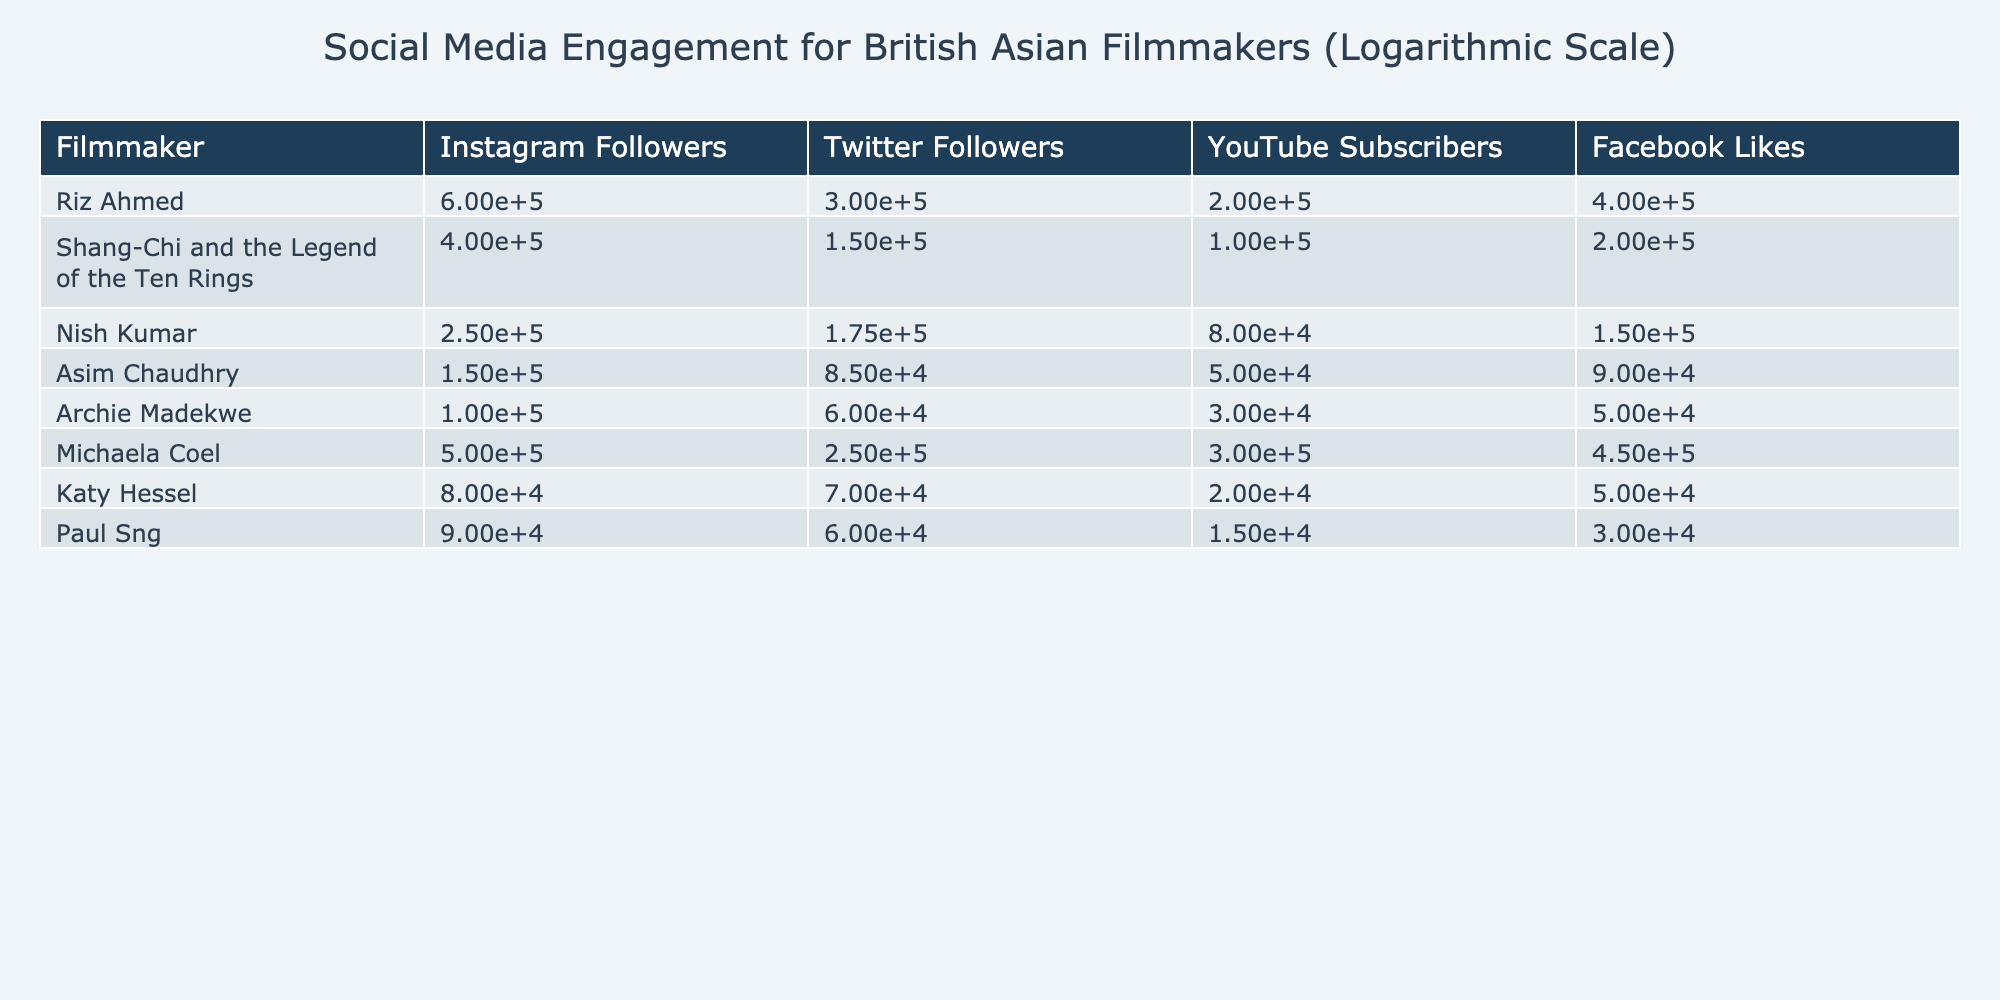What is the highest number of Instagram followers among the filmmakers listed? The table shows the Instagram follower counts, and Riz Ahmed has 600,000 followers, which is higher than all the other filmmakers listed.
Answer: 600000 How many more Twitter followers does Michaela Coel have than Paul Sng? Michaela Coel has 250,000 Twitter followers and Paul Sng has 60,000. To find the difference: 250,000 - 60,000 = 190,000.
Answer: 190000 Is Asim Chaudhry's Facebook Likes greater than Katy Hessel's? Asim Chaudhry has 90,000 Facebook Likes and Katy Hessel has 50,000. Since 90,000 is greater than 50,000, the statement is true.
Answer: Yes What is the average number of YouTube Subscribers for the filmmakers? The total number of YouTube Subscribers is 200,000 + 100,000 + 80,000 + 50,000 + 30,000 + 300,000 + 20,000 + 15,000 = 795,000. There are 8 filmmakers, so the average is 795,000 / 8 = 99,375.
Answer: 99375 Which filmmaker has the least number of Facebook Likes? In the table, the lowest Facebook Likes are for Paul Sng at 30,000. This is compared with the others, confirming that no filmmaker has less.
Answer: Paul Sng What percentage of Riz Ahmed's followers come from Instagram compared to his combined social media presence? Total followers across all platforms for Riz Ahmed is 600,000 (Instagram) + 300,000 (Twitter) + 200,000 (YouTube) + 400,000 (Facebook) = 1,500,000. The percentage of Instagram followers is (600,000 / 1,500,000) * 100 = 40%.
Answer: 40% How does the total Facebook Likes for Nish Kumar compare to that of Michaela Coel? Nish Kumar has 150,000 Facebook Likes, while Michaela Coel has 450,000. Michaela Coel has 450,000 - 150,000 = 300,000 more Likes.
Answer: 300000 more If we consider only the filmmakers with over 200,000 YouTube subscribers, how many unique platforms do they have data for? The filmmakers are Riz Ahmed (200,000), Michaela Coel (300,000), and Shang-Chi (100,000). All three filmmakers have data for 4 platforms each: Instagram, Twitter, YouTube, and Facebook, totaling 12 unique data points with three filmmakers.
Answer: 12 What is the total number of Instagram followers among the filmmakers listed below Katy Hessel? The filmmakers below Katy Hessel based on Instagram followers are Paul Sng (90,000), Archie Madekwe (100,000), Asim Chaudhry (150,000), Nish Kumar (250,000), and Riz Ahmed (600,000). Their total is 90,000 + 100,000 + 150,000 + 250,000 + 600,000 = 1,190,000.
Answer: 1190000 